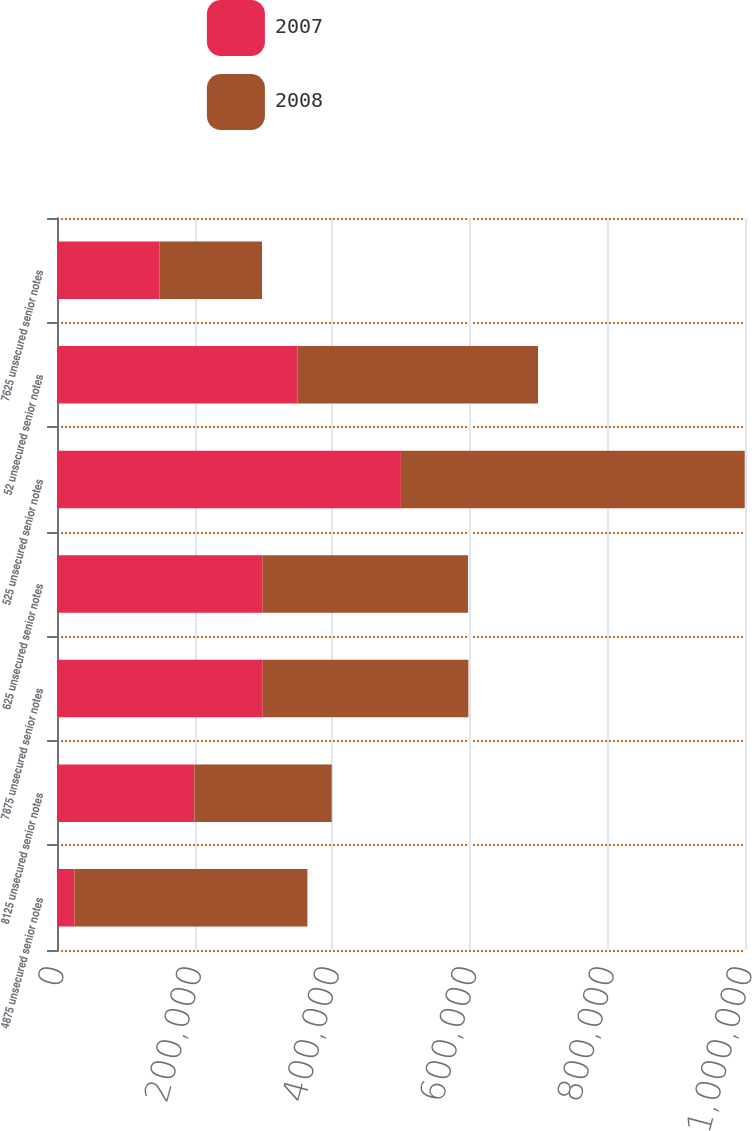<chart> <loc_0><loc_0><loc_500><loc_500><stacked_bar_chart><ecel><fcel>4875 unsecured senior notes<fcel>8125 unsecured senior notes<fcel>7875 unsecured senior notes<fcel>625 unsecured senior notes<fcel>525 unsecured senior notes<fcel>52 unsecured senior notes<fcel>7625 unsecured senior notes<nl><fcel>2007<fcel>25405<fcel>199736<fcel>298978<fcel>298816<fcel>499824<fcel>349602<fcel>149048<nl><fcel>2008<fcel>338545<fcel>199614<fcel>298934<fcel>298529<fcel>499790<fcel>349537<fcel>148940<nl></chart> 